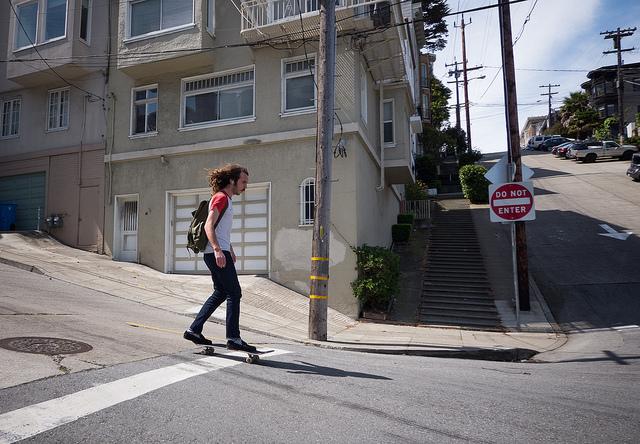Are any lights on?
Be succinct. No. Is this road flat?
Answer briefly. No. What direction is the arrow pointing in?
Short answer required. Down. Does the man have long hair?
Short answer required. Yes. What kind of shoes is the skater wearing?
Give a very brief answer. Vans. 